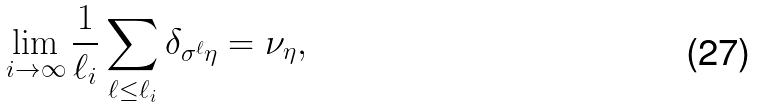Convert formula to latex. <formula><loc_0><loc_0><loc_500><loc_500>\lim _ { i \to \infty } \frac { 1 } { \ell _ { i } } \sum _ { \ell \leq \ell _ { i } } \delta _ { \sigma ^ { \ell } \eta } = \nu _ { \eta } ,</formula> 